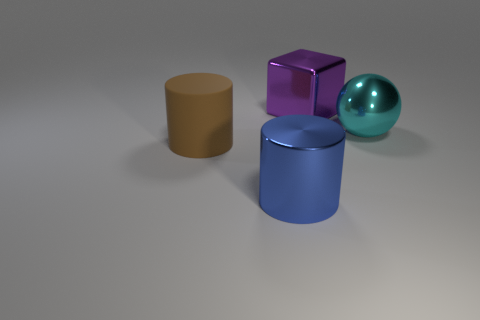What is the material of the big cylinder that is behind the big blue metallic object?
Offer a terse response. Rubber. Does the thing that is behind the cyan shiny thing have the same material as the big cyan ball?
Provide a short and direct response. Yes. There is a cyan thing that is the same size as the purple block; what shape is it?
Make the answer very short. Sphere. Are there fewer big brown objects right of the big cyan metal thing than large blue objects that are on the right side of the brown rubber object?
Keep it short and to the point. Yes. There is a purple thing; are there any big things in front of it?
Your answer should be very brief. Yes. There is a big cylinder behind the metallic thing that is in front of the big brown rubber cylinder; are there any large cylinders that are to the right of it?
Provide a short and direct response. Yes. There is a object in front of the brown object; is its shape the same as the big brown rubber object?
Give a very brief answer. Yes. There is a big cylinder that is made of the same material as the block; what is its color?
Offer a very short reply. Blue. How many purple things have the same material as the large purple block?
Provide a succinct answer. 0. There is a big cylinder right of the brown cylinder that is in front of the cyan shiny ball that is right of the cube; what color is it?
Offer a terse response. Blue. 